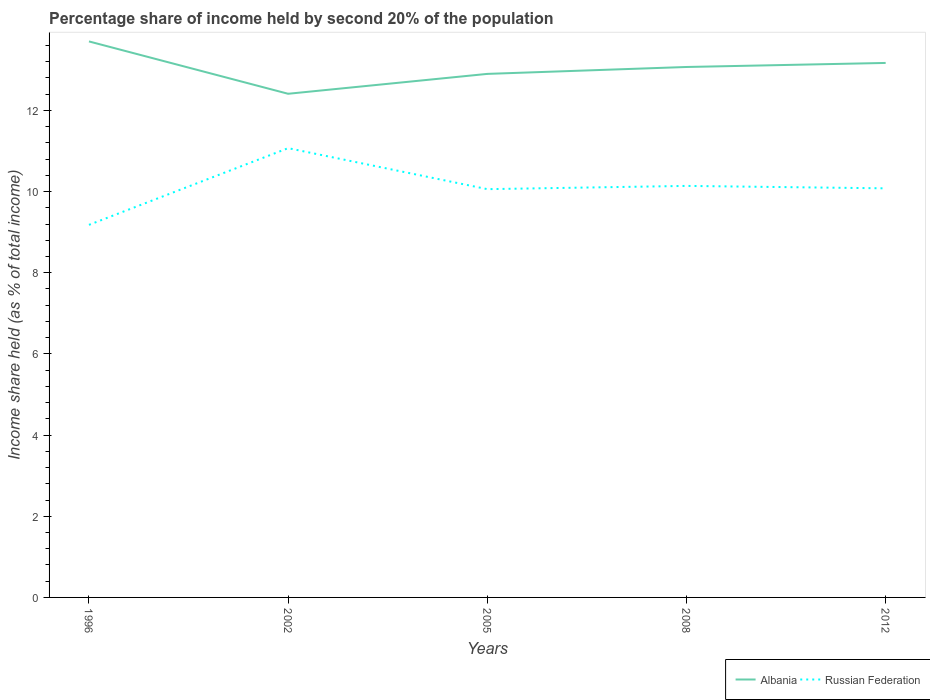How many different coloured lines are there?
Your answer should be very brief. 2. Does the line corresponding to Albania intersect with the line corresponding to Russian Federation?
Provide a short and direct response. No. Across all years, what is the maximum share of income held by second 20% of the population in Russian Federation?
Ensure brevity in your answer.  9.18. In which year was the share of income held by second 20% of the population in Albania maximum?
Keep it short and to the point. 2002. What is the total share of income held by second 20% of the population in Albania in the graph?
Give a very brief answer. -0.17. What is the difference between the highest and the second highest share of income held by second 20% of the population in Russian Federation?
Provide a succinct answer. 1.89. What is the difference between the highest and the lowest share of income held by second 20% of the population in Russian Federation?
Offer a very short reply. 2. How many lines are there?
Your response must be concise. 2. Are the values on the major ticks of Y-axis written in scientific E-notation?
Keep it short and to the point. No. Where does the legend appear in the graph?
Keep it short and to the point. Bottom right. How are the legend labels stacked?
Offer a terse response. Horizontal. What is the title of the graph?
Offer a very short reply. Percentage share of income held by second 20% of the population. Does "Swaziland" appear as one of the legend labels in the graph?
Keep it short and to the point. No. What is the label or title of the X-axis?
Your answer should be compact. Years. What is the label or title of the Y-axis?
Offer a terse response. Income share held (as % of total income). What is the Income share held (as % of total income) in Albania in 1996?
Offer a very short reply. 13.7. What is the Income share held (as % of total income) in Russian Federation in 1996?
Ensure brevity in your answer.  9.18. What is the Income share held (as % of total income) in Albania in 2002?
Provide a succinct answer. 12.41. What is the Income share held (as % of total income) in Russian Federation in 2002?
Provide a succinct answer. 11.07. What is the Income share held (as % of total income) of Albania in 2005?
Your answer should be very brief. 12.9. What is the Income share held (as % of total income) of Russian Federation in 2005?
Keep it short and to the point. 10.06. What is the Income share held (as % of total income) in Albania in 2008?
Your answer should be compact. 13.07. What is the Income share held (as % of total income) in Russian Federation in 2008?
Provide a short and direct response. 10.14. What is the Income share held (as % of total income) of Albania in 2012?
Offer a terse response. 13.17. What is the Income share held (as % of total income) in Russian Federation in 2012?
Offer a terse response. 10.08. Across all years, what is the maximum Income share held (as % of total income) in Russian Federation?
Provide a short and direct response. 11.07. Across all years, what is the minimum Income share held (as % of total income) in Albania?
Keep it short and to the point. 12.41. Across all years, what is the minimum Income share held (as % of total income) in Russian Federation?
Keep it short and to the point. 9.18. What is the total Income share held (as % of total income) of Albania in the graph?
Offer a very short reply. 65.25. What is the total Income share held (as % of total income) in Russian Federation in the graph?
Ensure brevity in your answer.  50.53. What is the difference between the Income share held (as % of total income) in Albania in 1996 and that in 2002?
Provide a succinct answer. 1.29. What is the difference between the Income share held (as % of total income) in Russian Federation in 1996 and that in 2002?
Provide a short and direct response. -1.89. What is the difference between the Income share held (as % of total income) in Russian Federation in 1996 and that in 2005?
Provide a succinct answer. -0.88. What is the difference between the Income share held (as % of total income) of Albania in 1996 and that in 2008?
Keep it short and to the point. 0.63. What is the difference between the Income share held (as % of total income) in Russian Federation in 1996 and that in 2008?
Give a very brief answer. -0.96. What is the difference between the Income share held (as % of total income) of Albania in 1996 and that in 2012?
Provide a short and direct response. 0.53. What is the difference between the Income share held (as % of total income) of Albania in 2002 and that in 2005?
Your response must be concise. -0.49. What is the difference between the Income share held (as % of total income) of Albania in 2002 and that in 2008?
Your answer should be compact. -0.66. What is the difference between the Income share held (as % of total income) in Russian Federation in 2002 and that in 2008?
Your answer should be compact. 0.93. What is the difference between the Income share held (as % of total income) of Albania in 2002 and that in 2012?
Give a very brief answer. -0.76. What is the difference between the Income share held (as % of total income) of Albania in 2005 and that in 2008?
Provide a short and direct response. -0.17. What is the difference between the Income share held (as % of total income) in Russian Federation in 2005 and that in 2008?
Provide a short and direct response. -0.08. What is the difference between the Income share held (as % of total income) in Albania in 2005 and that in 2012?
Ensure brevity in your answer.  -0.27. What is the difference between the Income share held (as % of total income) in Russian Federation in 2005 and that in 2012?
Keep it short and to the point. -0.02. What is the difference between the Income share held (as % of total income) of Albania in 2008 and that in 2012?
Your answer should be compact. -0.1. What is the difference between the Income share held (as % of total income) in Russian Federation in 2008 and that in 2012?
Make the answer very short. 0.06. What is the difference between the Income share held (as % of total income) in Albania in 1996 and the Income share held (as % of total income) in Russian Federation in 2002?
Your response must be concise. 2.63. What is the difference between the Income share held (as % of total income) in Albania in 1996 and the Income share held (as % of total income) in Russian Federation in 2005?
Provide a succinct answer. 3.64. What is the difference between the Income share held (as % of total income) of Albania in 1996 and the Income share held (as % of total income) of Russian Federation in 2008?
Offer a very short reply. 3.56. What is the difference between the Income share held (as % of total income) of Albania in 1996 and the Income share held (as % of total income) of Russian Federation in 2012?
Offer a terse response. 3.62. What is the difference between the Income share held (as % of total income) in Albania in 2002 and the Income share held (as % of total income) in Russian Federation in 2005?
Make the answer very short. 2.35. What is the difference between the Income share held (as % of total income) of Albania in 2002 and the Income share held (as % of total income) of Russian Federation in 2008?
Make the answer very short. 2.27. What is the difference between the Income share held (as % of total income) of Albania in 2002 and the Income share held (as % of total income) of Russian Federation in 2012?
Make the answer very short. 2.33. What is the difference between the Income share held (as % of total income) in Albania in 2005 and the Income share held (as % of total income) in Russian Federation in 2008?
Make the answer very short. 2.76. What is the difference between the Income share held (as % of total income) of Albania in 2005 and the Income share held (as % of total income) of Russian Federation in 2012?
Your answer should be very brief. 2.82. What is the difference between the Income share held (as % of total income) in Albania in 2008 and the Income share held (as % of total income) in Russian Federation in 2012?
Provide a short and direct response. 2.99. What is the average Income share held (as % of total income) in Albania per year?
Your answer should be very brief. 13.05. What is the average Income share held (as % of total income) of Russian Federation per year?
Keep it short and to the point. 10.11. In the year 1996, what is the difference between the Income share held (as % of total income) in Albania and Income share held (as % of total income) in Russian Federation?
Offer a very short reply. 4.52. In the year 2002, what is the difference between the Income share held (as % of total income) in Albania and Income share held (as % of total income) in Russian Federation?
Offer a terse response. 1.34. In the year 2005, what is the difference between the Income share held (as % of total income) in Albania and Income share held (as % of total income) in Russian Federation?
Ensure brevity in your answer.  2.84. In the year 2008, what is the difference between the Income share held (as % of total income) of Albania and Income share held (as % of total income) of Russian Federation?
Keep it short and to the point. 2.93. In the year 2012, what is the difference between the Income share held (as % of total income) of Albania and Income share held (as % of total income) of Russian Federation?
Provide a succinct answer. 3.09. What is the ratio of the Income share held (as % of total income) in Albania in 1996 to that in 2002?
Offer a very short reply. 1.1. What is the ratio of the Income share held (as % of total income) of Russian Federation in 1996 to that in 2002?
Your answer should be very brief. 0.83. What is the ratio of the Income share held (as % of total income) in Albania in 1996 to that in 2005?
Make the answer very short. 1.06. What is the ratio of the Income share held (as % of total income) of Russian Federation in 1996 to that in 2005?
Ensure brevity in your answer.  0.91. What is the ratio of the Income share held (as % of total income) in Albania in 1996 to that in 2008?
Your answer should be very brief. 1.05. What is the ratio of the Income share held (as % of total income) of Russian Federation in 1996 to that in 2008?
Offer a very short reply. 0.91. What is the ratio of the Income share held (as % of total income) in Albania in 1996 to that in 2012?
Give a very brief answer. 1.04. What is the ratio of the Income share held (as % of total income) in Russian Federation in 1996 to that in 2012?
Offer a terse response. 0.91. What is the ratio of the Income share held (as % of total income) in Albania in 2002 to that in 2005?
Offer a terse response. 0.96. What is the ratio of the Income share held (as % of total income) in Russian Federation in 2002 to that in 2005?
Give a very brief answer. 1.1. What is the ratio of the Income share held (as % of total income) of Albania in 2002 to that in 2008?
Offer a terse response. 0.95. What is the ratio of the Income share held (as % of total income) of Russian Federation in 2002 to that in 2008?
Ensure brevity in your answer.  1.09. What is the ratio of the Income share held (as % of total income) of Albania in 2002 to that in 2012?
Make the answer very short. 0.94. What is the ratio of the Income share held (as % of total income) in Russian Federation in 2002 to that in 2012?
Provide a short and direct response. 1.1. What is the ratio of the Income share held (as % of total income) of Albania in 2005 to that in 2008?
Ensure brevity in your answer.  0.99. What is the ratio of the Income share held (as % of total income) of Albania in 2005 to that in 2012?
Keep it short and to the point. 0.98. What is the ratio of the Income share held (as % of total income) of Russian Federation in 2005 to that in 2012?
Your response must be concise. 1. What is the ratio of the Income share held (as % of total income) of Albania in 2008 to that in 2012?
Make the answer very short. 0.99. What is the ratio of the Income share held (as % of total income) in Russian Federation in 2008 to that in 2012?
Offer a terse response. 1.01. What is the difference between the highest and the second highest Income share held (as % of total income) of Albania?
Make the answer very short. 0.53. What is the difference between the highest and the second highest Income share held (as % of total income) in Russian Federation?
Provide a succinct answer. 0.93. What is the difference between the highest and the lowest Income share held (as % of total income) in Albania?
Give a very brief answer. 1.29. What is the difference between the highest and the lowest Income share held (as % of total income) in Russian Federation?
Provide a succinct answer. 1.89. 